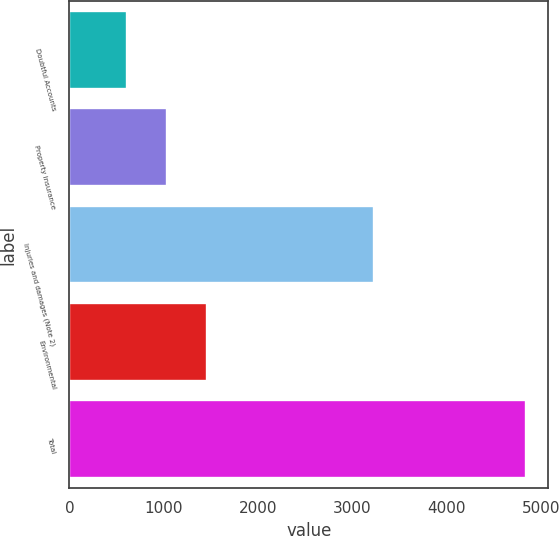Convert chart to OTSL. <chart><loc_0><loc_0><loc_500><loc_500><bar_chart><fcel>Doubtful Accounts<fcel>Property insurance<fcel>Injuries and damages (Note 2)<fcel>Environmental<fcel>Total<nl><fcel>612<fcel>1034.4<fcel>3231<fcel>1456.8<fcel>4836<nl></chart> 